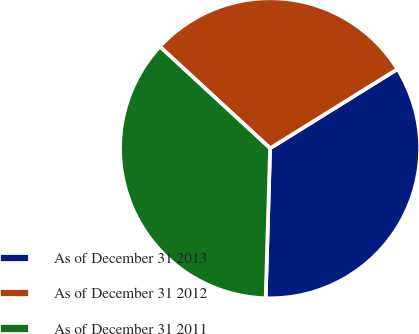Convert chart to OTSL. <chart><loc_0><loc_0><loc_500><loc_500><pie_chart><fcel>As of December 31 2013<fcel>As of December 31 2012<fcel>As of December 31 2011<nl><fcel>34.32%<fcel>29.29%<fcel>36.39%<nl></chart> 